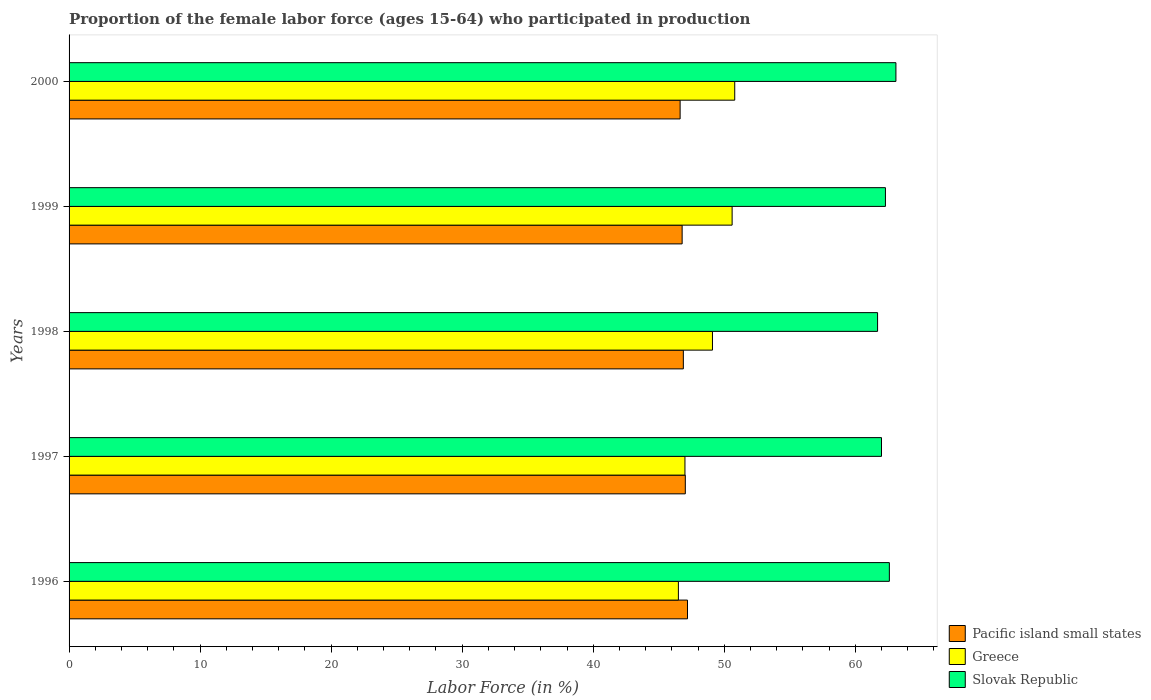How many different coloured bars are there?
Ensure brevity in your answer.  3. Are the number of bars per tick equal to the number of legend labels?
Give a very brief answer. Yes. How many bars are there on the 2nd tick from the bottom?
Offer a terse response. 3. In how many cases, is the number of bars for a given year not equal to the number of legend labels?
Provide a short and direct response. 0. What is the proportion of the female labor force who participated in production in Slovak Republic in 1997?
Provide a succinct answer. 62. Across all years, what is the maximum proportion of the female labor force who participated in production in Greece?
Your answer should be very brief. 50.8. Across all years, what is the minimum proportion of the female labor force who participated in production in Greece?
Keep it short and to the point. 46.5. In which year was the proportion of the female labor force who participated in production in Slovak Republic maximum?
Make the answer very short. 2000. In which year was the proportion of the female labor force who participated in production in Pacific island small states minimum?
Your answer should be compact. 2000. What is the total proportion of the female labor force who participated in production in Pacific island small states in the graph?
Your answer should be very brief. 234.52. What is the difference between the proportion of the female labor force who participated in production in Greece in 1997 and that in 2000?
Your answer should be compact. -3.8. What is the difference between the proportion of the female labor force who participated in production in Greece in 1996 and the proportion of the female labor force who participated in production in Pacific island small states in 1997?
Offer a very short reply. -0.53. What is the average proportion of the female labor force who participated in production in Pacific island small states per year?
Your response must be concise. 46.9. In the year 2000, what is the difference between the proportion of the female labor force who participated in production in Slovak Republic and proportion of the female labor force who participated in production in Pacific island small states?
Make the answer very short. 16.47. In how many years, is the proportion of the female labor force who participated in production in Slovak Republic greater than 16 %?
Provide a short and direct response. 5. What is the ratio of the proportion of the female labor force who participated in production in Slovak Republic in 1996 to that in 1998?
Ensure brevity in your answer.  1.01. Is the proportion of the female labor force who participated in production in Slovak Republic in 1997 less than that in 2000?
Your response must be concise. Yes. Is the difference between the proportion of the female labor force who participated in production in Slovak Republic in 1999 and 2000 greater than the difference between the proportion of the female labor force who participated in production in Pacific island small states in 1999 and 2000?
Your answer should be very brief. No. What is the difference between the highest and the second highest proportion of the female labor force who participated in production in Slovak Republic?
Give a very brief answer. 0.5. What is the difference between the highest and the lowest proportion of the female labor force who participated in production in Greece?
Ensure brevity in your answer.  4.3. What does the 1st bar from the top in 1997 represents?
Provide a succinct answer. Slovak Republic. What does the 1st bar from the bottom in 1998 represents?
Your answer should be compact. Pacific island small states. Are the values on the major ticks of X-axis written in scientific E-notation?
Offer a terse response. No. Does the graph contain grids?
Offer a very short reply. No. Where does the legend appear in the graph?
Offer a very short reply. Bottom right. How many legend labels are there?
Offer a very short reply. 3. How are the legend labels stacked?
Your answer should be compact. Vertical. What is the title of the graph?
Your answer should be very brief. Proportion of the female labor force (ages 15-64) who participated in production. Does "Malaysia" appear as one of the legend labels in the graph?
Your response must be concise. No. What is the label or title of the X-axis?
Make the answer very short. Labor Force (in %). What is the Labor Force (in %) of Pacific island small states in 1996?
Offer a terse response. 47.19. What is the Labor Force (in %) in Greece in 1996?
Offer a very short reply. 46.5. What is the Labor Force (in %) of Slovak Republic in 1996?
Offer a terse response. 62.6. What is the Labor Force (in %) of Pacific island small states in 1997?
Keep it short and to the point. 47.03. What is the Labor Force (in %) in Pacific island small states in 1998?
Your answer should be compact. 46.88. What is the Labor Force (in %) in Greece in 1998?
Provide a short and direct response. 49.1. What is the Labor Force (in %) of Slovak Republic in 1998?
Give a very brief answer. 61.7. What is the Labor Force (in %) in Pacific island small states in 1999?
Give a very brief answer. 46.79. What is the Labor Force (in %) in Greece in 1999?
Offer a terse response. 50.6. What is the Labor Force (in %) of Slovak Republic in 1999?
Make the answer very short. 62.3. What is the Labor Force (in %) of Pacific island small states in 2000?
Provide a short and direct response. 46.63. What is the Labor Force (in %) of Greece in 2000?
Ensure brevity in your answer.  50.8. What is the Labor Force (in %) in Slovak Republic in 2000?
Ensure brevity in your answer.  63.1. Across all years, what is the maximum Labor Force (in %) in Pacific island small states?
Your answer should be very brief. 47.19. Across all years, what is the maximum Labor Force (in %) of Greece?
Make the answer very short. 50.8. Across all years, what is the maximum Labor Force (in %) in Slovak Republic?
Make the answer very short. 63.1. Across all years, what is the minimum Labor Force (in %) in Pacific island small states?
Your answer should be very brief. 46.63. Across all years, what is the minimum Labor Force (in %) of Greece?
Offer a very short reply. 46.5. Across all years, what is the minimum Labor Force (in %) in Slovak Republic?
Give a very brief answer. 61.7. What is the total Labor Force (in %) of Pacific island small states in the graph?
Offer a very short reply. 234.52. What is the total Labor Force (in %) in Greece in the graph?
Keep it short and to the point. 244. What is the total Labor Force (in %) in Slovak Republic in the graph?
Keep it short and to the point. 311.7. What is the difference between the Labor Force (in %) of Pacific island small states in 1996 and that in 1997?
Provide a succinct answer. 0.17. What is the difference between the Labor Force (in %) of Greece in 1996 and that in 1997?
Ensure brevity in your answer.  -0.5. What is the difference between the Labor Force (in %) of Pacific island small states in 1996 and that in 1998?
Your response must be concise. 0.32. What is the difference between the Labor Force (in %) of Slovak Republic in 1996 and that in 1998?
Provide a succinct answer. 0.9. What is the difference between the Labor Force (in %) of Pacific island small states in 1996 and that in 1999?
Provide a short and direct response. 0.41. What is the difference between the Labor Force (in %) in Slovak Republic in 1996 and that in 1999?
Ensure brevity in your answer.  0.3. What is the difference between the Labor Force (in %) of Pacific island small states in 1996 and that in 2000?
Ensure brevity in your answer.  0.56. What is the difference between the Labor Force (in %) of Greece in 1996 and that in 2000?
Your response must be concise. -4.3. What is the difference between the Labor Force (in %) in Slovak Republic in 1996 and that in 2000?
Give a very brief answer. -0.5. What is the difference between the Labor Force (in %) of Pacific island small states in 1997 and that in 1998?
Give a very brief answer. 0.15. What is the difference between the Labor Force (in %) of Greece in 1997 and that in 1998?
Your answer should be very brief. -2.1. What is the difference between the Labor Force (in %) in Slovak Republic in 1997 and that in 1998?
Make the answer very short. 0.3. What is the difference between the Labor Force (in %) in Pacific island small states in 1997 and that in 1999?
Ensure brevity in your answer.  0.24. What is the difference between the Labor Force (in %) in Pacific island small states in 1997 and that in 2000?
Provide a short and direct response. 0.4. What is the difference between the Labor Force (in %) of Slovak Republic in 1997 and that in 2000?
Your response must be concise. -1.1. What is the difference between the Labor Force (in %) in Pacific island small states in 1998 and that in 1999?
Keep it short and to the point. 0.09. What is the difference between the Labor Force (in %) of Slovak Republic in 1998 and that in 1999?
Offer a very short reply. -0.6. What is the difference between the Labor Force (in %) in Pacific island small states in 1998 and that in 2000?
Your response must be concise. 0.25. What is the difference between the Labor Force (in %) of Greece in 1998 and that in 2000?
Provide a short and direct response. -1.7. What is the difference between the Labor Force (in %) in Pacific island small states in 1999 and that in 2000?
Offer a very short reply. 0.15. What is the difference between the Labor Force (in %) of Slovak Republic in 1999 and that in 2000?
Give a very brief answer. -0.8. What is the difference between the Labor Force (in %) in Pacific island small states in 1996 and the Labor Force (in %) in Greece in 1997?
Your answer should be compact. 0.19. What is the difference between the Labor Force (in %) in Pacific island small states in 1996 and the Labor Force (in %) in Slovak Republic in 1997?
Keep it short and to the point. -14.81. What is the difference between the Labor Force (in %) in Greece in 1996 and the Labor Force (in %) in Slovak Republic in 1997?
Provide a succinct answer. -15.5. What is the difference between the Labor Force (in %) in Pacific island small states in 1996 and the Labor Force (in %) in Greece in 1998?
Provide a short and direct response. -1.91. What is the difference between the Labor Force (in %) in Pacific island small states in 1996 and the Labor Force (in %) in Slovak Republic in 1998?
Ensure brevity in your answer.  -14.51. What is the difference between the Labor Force (in %) of Greece in 1996 and the Labor Force (in %) of Slovak Republic in 1998?
Your answer should be very brief. -15.2. What is the difference between the Labor Force (in %) in Pacific island small states in 1996 and the Labor Force (in %) in Greece in 1999?
Provide a succinct answer. -3.41. What is the difference between the Labor Force (in %) in Pacific island small states in 1996 and the Labor Force (in %) in Slovak Republic in 1999?
Keep it short and to the point. -15.11. What is the difference between the Labor Force (in %) of Greece in 1996 and the Labor Force (in %) of Slovak Republic in 1999?
Offer a very short reply. -15.8. What is the difference between the Labor Force (in %) in Pacific island small states in 1996 and the Labor Force (in %) in Greece in 2000?
Your response must be concise. -3.61. What is the difference between the Labor Force (in %) of Pacific island small states in 1996 and the Labor Force (in %) of Slovak Republic in 2000?
Provide a short and direct response. -15.91. What is the difference between the Labor Force (in %) of Greece in 1996 and the Labor Force (in %) of Slovak Republic in 2000?
Provide a succinct answer. -16.6. What is the difference between the Labor Force (in %) of Pacific island small states in 1997 and the Labor Force (in %) of Greece in 1998?
Offer a terse response. -2.07. What is the difference between the Labor Force (in %) in Pacific island small states in 1997 and the Labor Force (in %) in Slovak Republic in 1998?
Your answer should be compact. -14.67. What is the difference between the Labor Force (in %) in Greece in 1997 and the Labor Force (in %) in Slovak Republic in 1998?
Provide a short and direct response. -14.7. What is the difference between the Labor Force (in %) in Pacific island small states in 1997 and the Labor Force (in %) in Greece in 1999?
Offer a very short reply. -3.57. What is the difference between the Labor Force (in %) in Pacific island small states in 1997 and the Labor Force (in %) in Slovak Republic in 1999?
Offer a very short reply. -15.27. What is the difference between the Labor Force (in %) of Greece in 1997 and the Labor Force (in %) of Slovak Republic in 1999?
Ensure brevity in your answer.  -15.3. What is the difference between the Labor Force (in %) in Pacific island small states in 1997 and the Labor Force (in %) in Greece in 2000?
Make the answer very short. -3.77. What is the difference between the Labor Force (in %) in Pacific island small states in 1997 and the Labor Force (in %) in Slovak Republic in 2000?
Offer a terse response. -16.07. What is the difference between the Labor Force (in %) in Greece in 1997 and the Labor Force (in %) in Slovak Republic in 2000?
Give a very brief answer. -16.1. What is the difference between the Labor Force (in %) in Pacific island small states in 1998 and the Labor Force (in %) in Greece in 1999?
Offer a terse response. -3.72. What is the difference between the Labor Force (in %) in Pacific island small states in 1998 and the Labor Force (in %) in Slovak Republic in 1999?
Provide a short and direct response. -15.42. What is the difference between the Labor Force (in %) in Pacific island small states in 1998 and the Labor Force (in %) in Greece in 2000?
Your response must be concise. -3.92. What is the difference between the Labor Force (in %) in Pacific island small states in 1998 and the Labor Force (in %) in Slovak Republic in 2000?
Offer a terse response. -16.22. What is the difference between the Labor Force (in %) of Greece in 1998 and the Labor Force (in %) of Slovak Republic in 2000?
Your answer should be compact. -14. What is the difference between the Labor Force (in %) in Pacific island small states in 1999 and the Labor Force (in %) in Greece in 2000?
Your response must be concise. -4.01. What is the difference between the Labor Force (in %) in Pacific island small states in 1999 and the Labor Force (in %) in Slovak Republic in 2000?
Your answer should be very brief. -16.31. What is the difference between the Labor Force (in %) of Greece in 1999 and the Labor Force (in %) of Slovak Republic in 2000?
Your answer should be very brief. -12.5. What is the average Labor Force (in %) of Pacific island small states per year?
Offer a very short reply. 46.9. What is the average Labor Force (in %) of Greece per year?
Your response must be concise. 48.8. What is the average Labor Force (in %) in Slovak Republic per year?
Offer a very short reply. 62.34. In the year 1996, what is the difference between the Labor Force (in %) of Pacific island small states and Labor Force (in %) of Greece?
Your answer should be compact. 0.69. In the year 1996, what is the difference between the Labor Force (in %) of Pacific island small states and Labor Force (in %) of Slovak Republic?
Provide a succinct answer. -15.41. In the year 1996, what is the difference between the Labor Force (in %) in Greece and Labor Force (in %) in Slovak Republic?
Your response must be concise. -16.1. In the year 1997, what is the difference between the Labor Force (in %) in Pacific island small states and Labor Force (in %) in Greece?
Your answer should be very brief. 0.03. In the year 1997, what is the difference between the Labor Force (in %) of Pacific island small states and Labor Force (in %) of Slovak Republic?
Make the answer very short. -14.97. In the year 1997, what is the difference between the Labor Force (in %) of Greece and Labor Force (in %) of Slovak Republic?
Offer a very short reply. -15. In the year 1998, what is the difference between the Labor Force (in %) in Pacific island small states and Labor Force (in %) in Greece?
Offer a very short reply. -2.22. In the year 1998, what is the difference between the Labor Force (in %) in Pacific island small states and Labor Force (in %) in Slovak Republic?
Make the answer very short. -14.82. In the year 1999, what is the difference between the Labor Force (in %) of Pacific island small states and Labor Force (in %) of Greece?
Your answer should be very brief. -3.81. In the year 1999, what is the difference between the Labor Force (in %) of Pacific island small states and Labor Force (in %) of Slovak Republic?
Offer a terse response. -15.51. In the year 1999, what is the difference between the Labor Force (in %) in Greece and Labor Force (in %) in Slovak Republic?
Your answer should be very brief. -11.7. In the year 2000, what is the difference between the Labor Force (in %) of Pacific island small states and Labor Force (in %) of Greece?
Ensure brevity in your answer.  -4.17. In the year 2000, what is the difference between the Labor Force (in %) in Pacific island small states and Labor Force (in %) in Slovak Republic?
Offer a terse response. -16.47. What is the ratio of the Labor Force (in %) of Slovak Republic in 1996 to that in 1997?
Keep it short and to the point. 1.01. What is the ratio of the Labor Force (in %) of Pacific island small states in 1996 to that in 1998?
Provide a succinct answer. 1.01. What is the ratio of the Labor Force (in %) of Greece in 1996 to that in 1998?
Offer a very short reply. 0.95. What is the ratio of the Labor Force (in %) in Slovak Republic in 1996 to that in 1998?
Offer a very short reply. 1.01. What is the ratio of the Labor Force (in %) in Pacific island small states in 1996 to that in 1999?
Your response must be concise. 1.01. What is the ratio of the Labor Force (in %) of Greece in 1996 to that in 1999?
Give a very brief answer. 0.92. What is the ratio of the Labor Force (in %) of Slovak Republic in 1996 to that in 1999?
Give a very brief answer. 1. What is the ratio of the Labor Force (in %) of Pacific island small states in 1996 to that in 2000?
Your response must be concise. 1.01. What is the ratio of the Labor Force (in %) of Greece in 1996 to that in 2000?
Give a very brief answer. 0.92. What is the ratio of the Labor Force (in %) of Slovak Republic in 1996 to that in 2000?
Your answer should be compact. 0.99. What is the ratio of the Labor Force (in %) of Pacific island small states in 1997 to that in 1998?
Make the answer very short. 1. What is the ratio of the Labor Force (in %) in Greece in 1997 to that in 1998?
Offer a very short reply. 0.96. What is the ratio of the Labor Force (in %) of Greece in 1997 to that in 1999?
Keep it short and to the point. 0.93. What is the ratio of the Labor Force (in %) of Slovak Republic in 1997 to that in 1999?
Provide a short and direct response. 1. What is the ratio of the Labor Force (in %) in Pacific island small states in 1997 to that in 2000?
Provide a succinct answer. 1.01. What is the ratio of the Labor Force (in %) in Greece in 1997 to that in 2000?
Offer a terse response. 0.93. What is the ratio of the Labor Force (in %) in Slovak Republic in 1997 to that in 2000?
Your answer should be compact. 0.98. What is the ratio of the Labor Force (in %) of Pacific island small states in 1998 to that in 1999?
Give a very brief answer. 1. What is the ratio of the Labor Force (in %) in Greece in 1998 to that in 1999?
Make the answer very short. 0.97. What is the ratio of the Labor Force (in %) in Slovak Republic in 1998 to that in 1999?
Make the answer very short. 0.99. What is the ratio of the Labor Force (in %) in Greece in 1998 to that in 2000?
Your answer should be very brief. 0.97. What is the ratio of the Labor Force (in %) in Slovak Republic in 1998 to that in 2000?
Your response must be concise. 0.98. What is the ratio of the Labor Force (in %) of Pacific island small states in 1999 to that in 2000?
Provide a short and direct response. 1. What is the ratio of the Labor Force (in %) of Greece in 1999 to that in 2000?
Offer a terse response. 1. What is the ratio of the Labor Force (in %) of Slovak Republic in 1999 to that in 2000?
Your answer should be very brief. 0.99. What is the difference between the highest and the second highest Labor Force (in %) of Pacific island small states?
Keep it short and to the point. 0.17. What is the difference between the highest and the second highest Labor Force (in %) of Slovak Republic?
Offer a terse response. 0.5. What is the difference between the highest and the lowest Labor Force (in %) of Pacific island small states?
Keep it short and to the point. 0.56. What is the difference between the highest and the lowest Labor Force (in %) of Greece?
Offer a very short reply. 4.3. 